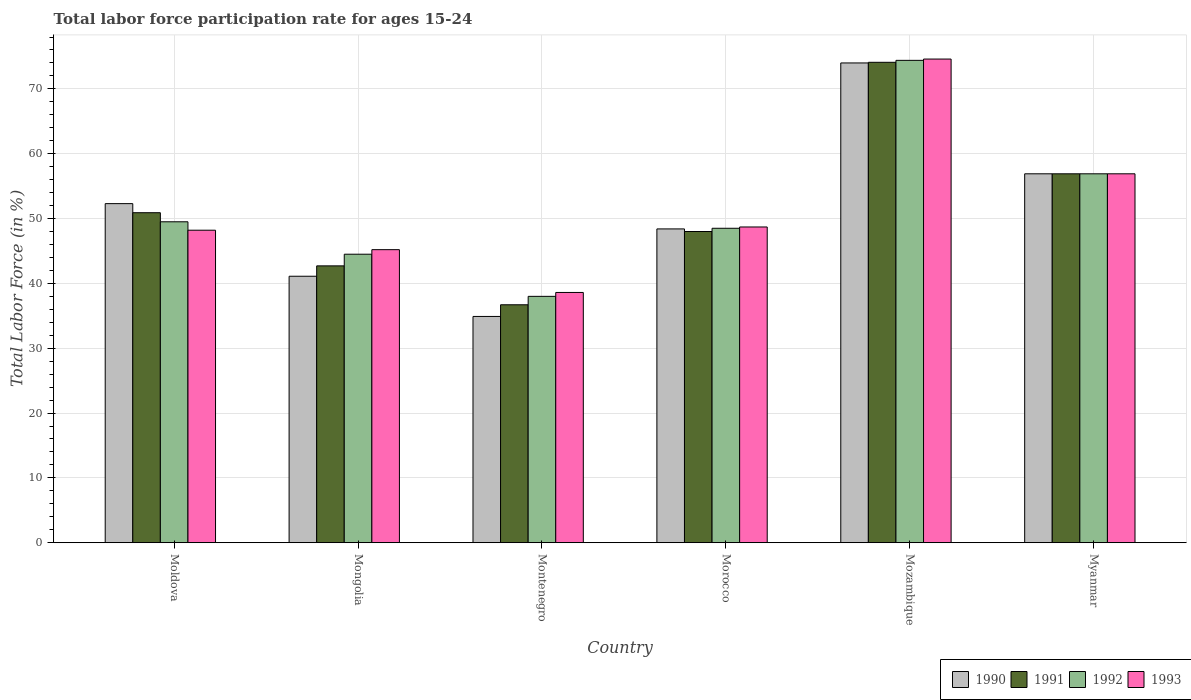How many groups of bars are there?
Provide a succinct answer. 6. Are the number of bars on each tick of the X-axis equal?
Give a very brief answer. Yes. How many bars are there on the 2nd tick from the left?
Ensure brevity in your answer.  4. How many bars are there on the 4th tick from the right?
Your answer should be very brief. 4. What is the label of the 1st group of bars from the left?
Give a very brief answer. Moldova. In how many cases, is the number of bars for a given country not equal to the number of legend labels?
Your response must be concise. 0. What is the labor force participation rate in 1992 in Montenegro?
Provide a succinct answer. 38. Across all countries, what is the maximum labor force participation rate in 1992?
Offer a very short reply. 74.4. Across all countries, what is the minimum labor force participation rate in 1992?
Make the answer very short. 38. In which country was the labor force participation rate in 1993 maximum?
Offer a very short reply. Mozambique. In which country was the labor force participation rate in 1992 minimum?
Make the answer very short. Montenegro. What is the total labor force participation rate in 1991 in the graph?
Provide a succinct answer. 309.3. What is the difference between the labor force participation rate in 1990 in Mongolia and the labor force participation rate in 1992 in Montenegro?
Make the answer very short. 3.1. What is the average labor force participation rate in 1993 per country?
Your answer should be compact. 52.03. What is the difference between the labor force participation rate of/in 1992 and labor force participation rate of/in 1991 in Montenegro?
Your answer should be very brief. 1.3. In how many countries, is the labor force participation rate in 1991 greater than 6 %?
Give a very brief answer. 6. What is the ratio of the labor force participation rate in 1990 in Mongolia to that in Mozambique?
Offer a very short reply. 0.56. Is the labor force participation rate in 1993 in Montenegro less than that in Myanmar?
Your answer should be very brief. Yes. What is the difference between the highest and the second highest labor force participation rate in 1990?
Make the answer very short. -17.1. What is the difference between the highest and the lowest labor force participation rate in 1992?
Make the answer very short. 36.4. In how many countries, is the labor force participation rate in 1990 greater than the average labor force participation rate in 1990 taken over all countries?
Keep it short and to the point. 3. Is it the case that in every country, the sum of the labor force participation rate in 1992 and labor force participation rate in 1990 is greater than the sum of labor force participation rate in 1993 and labor force participation rate in 1991?
Provide a short and direct response. No. Is it the case that in every country, the sum of the labor force participation rate in 1991 and labor force participation rate in 1993 is greater than the labor force participation rate in 1990?
Your answer should be very brief. Yes. How many bars are there?
Give a very brief answer. 24. Are the values on the major ticks of Y-axis written in scientific E-notation?
Keep it short and to the point. No. Does the graph contain any zero values?
Give a very brief answer. No. Does the graph contain grids?
Your answer should be very brief. Yes. How are the legend labels stacked?
Your response must be concise. Horizontal. What is the title of the graph?
Make the answer very short. Total labor force participation rate for ages 15-24. Does "1986" appear as one of the legend labels in the graph?
Offer a very short reply. No. What is the label or title of the X-axis?
Make the answer very short. Country. What is the Total Labor Force (in %) of 1990 in Moldova?
Your answer should be compact. 52.3. What is the Total Labor Force (in %) in 1991 in Moldova?
Make the answer very short. 50.9. What is the Total Labor Force (in %) in 1992 in Moldova?
Offer a very short reply. 49.5. What is the Total Labor Force (in %) in 1993 in Moldova?
Offer a terse response. 48.2. What is the Total Labor Force (in %) of 1990 in Mongolia?
Your response must be concise. 41.1. What is the Total Labor Force (in %) of 1991 in Mongolia?
Ensure brevity in your answer.  42.7. What is the Total Labor Force (in %) in 1992 in Mongolia?
Make the answer very short. 44.5. What is the Total Labor Force (in %) of 1993 in Mongolia?
Offer a terse response. 45.2. What is the Total Labor Force (in %) in 1990 in Montenegro?
Give a very brief answer. 34.9. What is the Total Labor Force (in %) in 1991 in Montenegro?
Your answer should be very brief. 36.7. What is the Total Labor Force (in %) of 1992 in Montenegro?
Offer a very short reply. 38. What is the Total Labor Force (in %) in 1993 in Montenegro?
Provide a succinct answer. 38.6. What is the Total Labor Force (in %) in 1990 in Morocco?
Give a very brief answer. 48.4. What is the Total Labor Force (in %) in 1992 in Morocco?
Make the answer very short. 48.5. What is the Total Labor Force (in %) in 1993 in Morocco?
Your answer should be very brief. 48.7. What is the Total Labor Force (in %) in 1990 in Mozambique?
Provide a succinct answer. 74. What is the Total Labor Force (in %) in 1991 in Mozambique?
Your response must be concise. 74.1. What is the Total Labor Force (in %) of 1992 in Mozambique?
Your answer should be compact. 74.4. What is the Total Labor Force (in %) of 1993 in Mozambique?
Give a very brief answer. 74.6. What is the Total Labor Force (in %) of 1990 in Myanmar?
Provide a short and direct response. 56.9. What is the Total Labor Force (in %) in 1991 in Myanmar?
Your response must be concise. 56.9. What is the Total Labor Force (in %) in 1992 in Myanmar?
Offer a very short reply. 56.9. What is the Total Labor Force (in %) in 1993 in Myanmar?
Offer a very short reply. 56.9. Across all countries, what is the maximum Total Labor Force (in %) in 1991?
Keep it short and to the point. 74.1. Across all countries, what is the maximum Total Labor Force (in %) of 1992?
Give a very brief answer. 74.4. Across all countries, what is the maximum Total Labor Force (in %) in 1993?
Provide a succinct answer. 74.6. Across all countries, what is the minimum Total Labor Force (in %) in 1990?
Your answer should be compact. 34.9. Across all countries, what is the minimum Total Labor Force (in %) in 1991?
Ensure brevity in your answer.  36.7. Across all countries, what is the minimum Total Labor Force (in %) of 1992?
Provide a succinct answer. 38. Across all countries, what is the minimum Total Labor Force (in %) of 1993?
Offer a terse response. 38.6. What is the total Total Labor Force (in %) in 1990 in the graph?
Make the answer very short. 307.6. What is the total Total Labor Force (in %) of 1991 in the graph?
Your response must be concise. 309.3. What is the total Total Labor Force (in %) of 1992 in the graph?
Offer a very short reply. 311.8. What is the total Total Labor Force (in %) in 1993 in the graph?
Ensure brevity in your answer.  312.2. What is the difference between the Total Labor Force (in %) of 1993 in Moldova and that in Mongolia?
Your answer should be very brief. 3. What is the difference between the Total Labor Force (in %) in 1992 in Moldova and that in Montenegro?
Offer a terse response. 11.5. What is the difference between the Total Labor Force (in %) of 1991 in Moldova and that in Morocco?
Your answer should be very brief. 2.9. What is the difference between the Total Labor Force (in %) of 1992 in Moldova and that in Morocco?
Offer a terse response. 1. What is the difference between the Total Labor Force (in %) in 1993 in Moldova and that in Morocco?
Offer a very short reply. -0.5. What is the difference between the Total Labor Force (in %) in 1990 in Moldova and that in Mozambique?
Give a very brief answer. -21.7. What is the difference between the Total Labor Force (in %) of 1991 in Moldova and that in Mozambique?
Provide a short and direct response. -23.2. What is the difference between the Total Labor Force (in %) of 1992 in Moldova and that in Mozambique?
Offer a very short reply. -24.9. What is the difference between the Total Labor Force (in %) in 1993 in Moldova and that in Mozambique?
Your answer should be compact. -26.4. What is the difference between the Total Labor Force (in %) in 1990 in Moldova and that in Myanmar?
Offer a very short reply. -4.6. What is the difference between the Total Labor Force (in %) in 1991 in Moldova and that in Myanmar?
Keep it short and to the point. -6. What is the difference between the Total Labor Force (in %) of 1991 in Mongolia and that in Montenegro?
Make the answer very short. 6. What is the difference between the Total Labor Force (in %) of 1992 in Mongolia and that in Montenegro?
Offer a terse response. 6.5. What is the difference between the Total Labor Force (in %) in 1993 in Mongolia and that in Montenegro?
Keep it short and to the point. 6.6. What is the difference between the Total Labor Force (in %) of 1990 in Mongolia and that in Morocco?
Your answer should be very brief. -7.3. What is the difference between the Total Labor Force (in %) of 1992 in Mongolia and that in Morocco?
Provide a succinct answer. -4. What is the difference between the Total Labor Force (in %) of 1990 in Mongolia and that in Mozambique?
Make the answer very short. -32.9. What is the difference between the Total Labor Force (in %) in 1991 in Mongolia and that in Mozambique?
Make the answer very short. -31.4. What is the difference between the Total Labor Force (in %) of 1992 in Mongolia and that in Mozambique?
Provide a short and direct response. -29.9. What is the difference between the Total Labor Force (in %) of 1993 in Mongolia and that in Mozambique?
Your response must be concise. -29.4. What is the difference between the Total Labor Force (in %) of 1990 in Mongolia and that in Myanmar?
Your response must be concise. -15.8. What is the difference between the Total Labor Force (in %) in 1992 in Mongolia and that in Myanmar?
Make the answer very short. -12.4. What is the difference between the Total Labor Force (in %) of 1991 in Montenegro and that in Morocco?
Your response must be concise. -11.3. What is the difference between the Total Labor Force (in %) in 1990 in Montenegro and that in Mozambique?
Your answer should be very brief. -39.1. What is the difference between the Total Labor Force (in %) in 1991 in Montenegro and that in Mozambique?
Your answer should be compact. -37.4. What is the difference between the Total Labor Force (in %) in 1992 in Montenegro and that in Mozambique?
Your answer should be very brief. -36.4. What is the difference between the Total Labor Force (in %) in 1993 in Montenegro and that in Mozambique?
Offer a very short reply. -36. What is the difference between the Total Labor Force (in %) of 1990 in Montenegro and that in Myanmar?
Make the answer very short. -22. What is the difference between the Total Labor Force (in %) in 1991 in Montenegro and that in Myanmar?
Provide a short and direct response. -20.2. What is the difference between the Total Labor Force (in %) in 1992 in Montenegro and that in Myanmar?
Give a very brief answer. -18.9. What is the difference between the Total Labor Force (in %) of 1993 in Montenegro and that in Myanmar?
Keep it short and to the point. -18.3. What is the difference between the Total Labor Force (in %) of 1990 in Morocco and that in Mozambique?
Your answer should be very brief. -25.6. What is the difference between the Total Labor Force (in %) of 1991 in Morocco and that in Mozambique?
Keep it short and to the point. -26.1. What is the difference between the Total Labor Force (in %) in 1992 in Morocco and that in Mozambique?
Ensure brevity in your answer.  -25.9. What is the difference between the Total Labor Force (in %) in 1993 in Morocco and that in Mozambique?
Offer a very short reply. -25.9. What is the difference between the Total Labor Force (in %) of 1990 in Morocco and that in Myanmar?
Provide a succinct answer. -8.5. What is the difference between the Total Labor Force (in %) in 1991 in Morocco and that in Myanmar?
Provide a short and direct response. -8.9. What is the difference between the Total Labor Force (in %) of 1993 in Morocco and that in Myanmar?
Provide a short and direct response. -8.2. What is the difference between the Total Labor Force (in %) of 1992 in Mozambique and that in Myanmar?
Provide a short and direct response. 17.5. What is the difference between the Total Labor Force (in %) of 1993 in Mozambique and that in Myanmar?
Ensure brevity in your answer.  17.7. What is the difference between the Total Labor Force (in %) of 1990 in Moldova and the Total Labor Force (in %) of 1992 in Mongolia?
Keep it short and to the point. 7.8. What is the difference between the Total Labor Force (in %) in 1990 in Moldova and the Total Labor Force (in %) in 1993 in Montenegro?
Provide a succinct answer. 13.7. What is the difference between the Total Labor Force (in %) of 1991 in Moldova and the Total Labor Force (in %) of 1992 in Montenegro?
Provide a short and direct response. 12.9. What is the difference between the Total Labor Force (in %) of 1991 in Moldova and the Total Labor Force (in %) of 1993 in Montenegro?
Your answer should be very brief. 12.3. What is the difference between the Total Labor Force (in %) in 1992 in Moldova and the Total Labor Force (in %) in 1993 in Montenegro?
Give a very brief answer. 10.9. What is the difference between the Total Labor Force (in %) of 1991 in Moldova and the Total Labor Force (in %) of 1992 in Morocco?
Offer a terse response. 2.4. What is the difference between the Total Labor Force (in %) in 1991 in Moldova and the Total Labor Force (in %) in 1993 in Morocco?
Your response must be concise. 2.2. What is the difference between the Total Labor Force (in %) in 1992 in Moldova and the Total Labor Force (in %) in 1993 in Morocco?
Give a very brief answer. 0.8. What is the difference between the Total Labor Force (in %) of 1990 in Moldova and the Total Labor Force (in %) of 1991 in Mozambique?
Provide a succinct answer. -21.8. What is the difference between the Total Labor Force (in %) in 1990 in Moldova and the Total Labor Force (in %) in 1992 in Mozambique?
Offer a terse response. -22.1. What is the difference between the Total Labor Force (in %) in 1990 in Moldova and the Total Labor Force (in %) in 1993 in Mozambique?
Ensure brevity in your answer.  -22.3. What is the difference between the Total Labor Force (in %) in 1991 in Moldova and the Total Labor Force (in %) in 1992 in Mozambique?
Provide a succinct answer. -23.5. What is the difference between the Total Labor Force (in %) in 1991 in Moldova and the Total Labor Force (in %) in 1993 in Mozambique?
Provide a succinct answer. -23.7. What is the difference between the Total Labor Force (in %) in 1992 in Moldova and the Total Labor Force (in %) in 1993 in Mozambique?
Provide a succinct answer. -25.1. What is the difference between the Total Labor Force (in %) of 1990 in Moldova and the Total Labor Force (in %) of 1991 in Myanmar?
Ensure brevity in your answer.  -4.6. What is the difference between the Total Labor Force (in %) in 1990 in Moldova and the Total Labor Force (in %) in 1992 in Myanmar?
Provide a short and direct response. -4.6. What is the difference between the Total Labor Force (in %) of 1990 in Moldova and the Total Labor Force (in %) of 1993 in Myanmar?
Offer a very short reply. -4.6. What is the difference between the Total Labor Force (in %) of 1991 in Moldova and the Total Labor Force (in %) of 1992 in Myanmar?
Ensure brevity in your answer.  -6. What is the difference between the Total Labor Force (in %) in 1990 in Mongolia and the Total Labor Force (in %) in 1991 in Montenegro?
Offer a very short reply. 4.4. What is the difference between the Total Labor Force (in %) of 1990 in Mongolia and the Total Labor Force (in %) of 1993 in Montenegro?
Provide a short and direct response. 2.5. What is the difference between the Total Labor Force (in %) in 1992 in Mongolia and the Total Labor Force (in %) in 1993 in Montenegro?
Your answer should be very brief. 5.9. What is the difference between the Total Labor Force (in %) in 1990 in Mongolia and the Total Labor Force (in %) in 1993 in Morocco?
Make the answer very short. -7.6. What is the difference between the Total Labor Force (in %) in 1991 in Mongolia and the Total Labor Force (in %) in 1992 in Morocco?
Keep it short and to the point. -5.8. What is the difference between the Total Labor Force (in %) in 1991 in Mongolia and the Total Labor Force (in %) in 1993 in Morocco?
Provide a short and direct response. -6. What is the difference between the Total Labor Force (in %) of 1992 in Mongolia and the Total Labor Force (in %) of 1993 in Morocco?
Your answer should be compact. -4.2. What is the difference between the Total Labor Force (in %) in 1990 in Mongolia and the Total Labor Force (in %) in 1991 in Mozambique?
Give a very brief answer. -33. What is the difference between the Total Labor Force (in %) of 1990 in Mongolia and the Total Labor Force (in %) of 1992 in Mozambique?
Your response must be concise. -33.3. What is the difference between the Total Labor Force (in %) of 1990 in Mongolia and the Total Labor Force (in %) of 1993 in Mozambique?
Your response must be concise. -33.5. What is the difference between the Total Labor Force (in %) of 1991 in Mongolia and the Total Labor Force (in %) of 1992 in Mozambique?
Make the answer very short. -31.7. What is the difference between the Total Labor Force (in %) of 1991 in Mongolia and the Total Labor Force (in %) of 1993 in Mozambique?
Provide a succinct answer. -31.9. What is the difference between the Total Labor Force (in %) of 1992 in Mongolia and the Total Labor Force (in %) of 1993 in Mozambique?
Provide a short and direct response. -30.1. What is the difference between the Total Labor Force (in %) in 1990 in Mongolia and the Total Labor Force (in %) in 1991 in Myanmar?
Your answer should be compact. -15.8. What is the difference between the Total Labor Force (in %) in 1990 in Mongolia and the Total Labor Force (in %) in 1992 in Myanmar?
Your response must be concise. -15.8. What is the difference between the Total Labor Force (in %) of 1990 in Mongolia and the Total Labor Force (in %) of 1993 in Myanmar?
Keep it short and to the point. -15.8. What is the difference between the Total Labor Force (in %) in 1991 in Mongolia and the Total Labor Force (in %) in 1992 in Myanmar?
Your answer should be compact. -14.2. What is the difference between the Total Labor Force (in %) of 1990 in Montenegro and the Total Labor Force (in %) of 1993 in Morocco?
Offer a very short reply. -13.8. What is the difference between the Total Labor Force (in %) in 1991 in Montenegro and the Total Labor Force (in %) in 1992 in Morocco?
Give a very brief answer. -11.8. What is the difference between the Total Labor Force (in %) of 1991 in Montenegro and the Total Labor Force (in %) of 1993 in Morocco?
Provide a succinct answer. -12. What is the difference between the Total Labor Force (in %) of 1990 in Montenegro and the Total Labor Force (in %) of 1991 in Mozambique?
Ensure brevity in your answer.  -39.2. What is the difference between the Total Labor Force (in %) of 1990 in Montenegro and the Total Labor Force (in %) of 1992 in Mozambique?
Keep it short and to the point. -39.5. What is the difference between the Total Labor Force (in %) of 1990 in Montenegro and the Total Labor Force (in %) of 1993 in Mozambique?
Give a very brief answer. -39.7. What is the difference between the Total Labor Force (in %) of 1991 in Montenegro and the Total Labor Force (in %) of 1992 in Mozambique?
Ensure brevity in your answer.  -37.7. What is the difference between the Total Labor Force (in %) in 1991 in Montenegro and the Total Labor Force (in %) in 1993 in Mozambique?
Your response must be concise. -37.9. What is the difference between the Total Labor Force (in %) of 1992 in Montenegro and the Total Labor Force (in %) of 1993 in Mozambique?
Ensure brevity in your answer.  -36.6. What is the difference between the Total Labor Force (in %) of 1991 in Montenegro and the Total Labor Force (in %) of 1992 in Myanmar?
Give a very brief answer. -20.2. What is the difference between the Total Labor Force (in %) in 1991 in Montenegro and the Total Labor Force (in %) in 1993 in Myanmar?
Keep it short and to the point. -20.2. What is the difference between the Total Labor Force (in %) in 1992 in Montenegro and the Total Labor Force (in %) in 1993 in Myanmar?
Provide a short and direct response. -18.9. What is the difference between the Total Labor Force (in %) in 1990 in Morocco and the Total Labor Force (in %) in 1991 in Mozambique?
Your response must be concise. -25.7. What is the difference between the Total Labor Force (in %) in 1990 in Morocco and the Total Labor Force (in %) in 1993 in Mozambique?
Your answer should be compact. -26.2. What is the difference between the Total Labor Force (in %) of 1991 in Morocco and the Total Labor Force (in %) of 1992 in Mozambique?
Your response must be concise. -26.4. What is the difference between the Total Labor Force (in %) of 1991 in Morocco and the Total Labor Force (in %) of 1993 in Mozambique?
Your answer should be compact. -26.6. What is the difference between the Total Labor Force (in %) in 1992 in Morocco and the Total Labor Force (in %) in 1993 in Mozambique?
Your answer should be very brief. -26.1. What is the difference between the Total Labor Force (in %) of 1990 in Morocco and the Total Labor Force (in %) of 1991 in Myanmar?
Keep it short and to the point. -8.5. What is the difference between the Total Labor Force (in %) in 1990 in Morocco and the Total Labor Force (in %) in 1992 in Myanmar?
Offer a very short reply. -8.5. What is the difference between the Total Labor Force (in %) in 1991 in Morocco and the Total Labor Force (in %) in 1992 in Myanmar?
Your response must be concise. -8.9. What is the difference between the Total Labor Force (in %) of 1991 in Morocco and the Total Labor Force (in %) of 1993 in Myanmar?
Your answer should be very brief. -8.9. What is the difference between the Total Labor Force (in %) of 1992 in Morocco and the Total Labor Force (in %) of 1993 in Myanmar?
Ensure brevity in your answer.  -8.4. What is the difference between the Total Labor Force (in %) of 1990 in Mozambique and the Total Labor Force (in %) of 1991 in Myanmar?
Provide a succinct answer. 17.1. What is the difference between the Total Labor Force (in %) of 1992 in Mozambique and the Total Labor Force (in %) of 1993 in Myanmar?
Provide a succinct answer. 17.5. What is the average Total Labor Force (in %) in 1990 per country?
Your answer should be compact. 51.27. What is the average Total Labor Force (in %) in 1991 per country?
Offer a terse response. 51.55. What is the average Total Labor Force (in %) of 1992 per country?
Give a very brief answer. 51.97. What is the average Total Labor Force (in %) in 1993 per country?
Offer a terse response. 52.03. What is the difference between the Total Labor Force (in %) in 1990 and Total Labor Force (in %) in 1992 in Moldova?
Ensure brevity in your answer.  2.8. What is the difference between the Total Labor Force (in %) of 1990 and Total Labor Force (in %) of 1993 in Moldova?
Provide a succinct answer. 4.1. What is the difference between the Total Labor Force (in %) in 1991 and Total Labor Force (in %) in 1992 in Moldova?
Provide a succinct answer. 1.4. What is the difference between the Total Labor Force (in %) in 1990 and Total Labor Force (in %) in 1992 in Mongolia?
Keep it short and to the point. -3.4. What is the difference between the Total Labor Force (in %) of 1991 and Total Labor Force (in %) of 1992 in Mongolia?
Your response must be concise. -1.8. What is the difference between the Total Labor Force (in %) of 1992 and Total Labor Force (in %) of 1993 in Mongolia?
Make the answer very short. -0.7. What is the difference between the Total Labor Force (in %) of 1990 and Total Labor Force (in %) of 1992 in Montenegro?
Make the answer very short. -3.1. What is the difference between the Total Labor Force (in %) in 1991 and Total Labor Force (in %) in 1992 in Montenegro?
Your response must be concise. -1.3. What is the difference between the Total Labor Force (in %) in 1992 and Total Labor Force (in %) in 1993 in Montenegro?
Make the answer very short. -0.6. What is the difference between the Total Labor Force (in %) in 1991 and Total Labor Force (in %) in 1992 in Morocco?
Offer a very short reply. -0.5. What is the difference between the Total Labor Force (in %) in 1990 and Total Labor Force (in %) in 1991 in Mozambique?
Give a very brief answer. -0.1. What is the difference between the Total Labor Force (in %) of 1990 and Total Labor Force (in %) of 1992 in Mozambique?
Your answer should be compact. -0.4. What is the difference between the Total Labor Force (in %) in 1990 and Total Labor Force (in %) in 1993 in Mozambique?
Your answer should be very brief. -0.6. What is the difference between the Total Labor Force (in %) of 1991 and Total Labor Force (in %) of 1993 in Myanmar?
Offer a terse response. 0. What is the difference between the Total Labor Force (in %) of 1992 and Total Labor Force (in %) of 1993 in Myanmar?
Your answer should be very brief. 0. What is the ratio of the Total Labor Force (in %) of 1990 in Moldova to that in Mongolia?
Give a very brief answer. 1.27. What is the ratio of the Total Labor Force (in %) in 1991 in Moldova to that in Mongolia?
Make the answer very short. 1.19. What is the ratio of the Total Labor Force (in %) in 1992 in Moldova to that in Mongolia?
Offer a very short reply. 1.11. What is the ratio of the Total Labor Force (in %) of 1993 in Moldova to that in Mongolia?
Give a very brief answer. 1.07. What is the ratio of the Total Labor Force (in %) of 1990 in Moldova to that in Montenegro?
Offer a terse response. 1.5. What is the ratio of the Total Labor Force (in %) of 1991 in Moldova to that in Montenegro?
Offer a very short reply. 1.39. What is the ratio of the Total Labor Force (in %) of 1992 in Moldova to that in Montenegro?
Your response must be concise. 1.3. What is the ratio of the Total Labor Force (in %) in 1993 in Moldova to that in Montenegro?
Your response must be concise. 1.25. What is the ratio of the Total Labor Force (in %) in 1990 in Moldova to that in Morocco?
Keep it short and to the point. 1.08. What is the ratio of the Total Labor Force (in %) of 1991 in Moldova to that in Morocco?
Offer a terse response. 1.06. What is the ratio of the Total Labor Force (in %) in 1992 in Moldova to that in Morocco?
Ensure brevity in your answer.  1.02. What is the ratio of the Total Labor Force (in %) in 1990 in Moldova to that in Mozambique?
Your answer should be compact. 0.71. What is the ratio of the Total Labor Force (in %) of 1991 in Moldova to that in Mozambique?
Offer a very short reply. 0.69. What is the ratio of the Total Labor Force (in %) of 1992 in Moldova to that in Mozambique?
Ensure brevity in your answer.  0.67. What is the ratio of the Total Labor Force (in %) of 1993 in Moldova to that in Mozambique?
Keep it short and to the point. 0.65. What is the ratio of the Total Labor Force (in %) of 1990 in Moldova to that in Myanmar?
Provide a succinct answer. 0.92. What is the ratio of the Total Labor Force (in %) in 1991 in Moldova to that in Myanmar?
Make the answer very short. 0.89. What is the ratio of the Total Labor Force (in %) of 1992 in Moldova to that in Myanmar?
Your answer should be compact. 0.87. What is the ratio of the Total Labor Force (in %) in 1993 in Moldova to that in Myanmar?
Your answer should be very brief. 0.85. What is the ratio of the Total Labor Force (in %) in 1990 in Mongolia to that in Montenegro?
Offer a very short reply. 1.18. What is the ratio of the Total Labor Force (in %) in 1991 in Mongolia to that in Montenegro?
Give a very brief answer. 1.16. What is the ratio of the Total Labor Force (in %) of 1992 in Mongolia to that in Montenegro?
Offer a very short reply. 1.17. What is the ratio of the Total Labor Force (in %) in 1993 in Mongolia to that in Montenegro?
Make the answer very short. 1.17. What is the ratio of the Total Labor Force (in %) in 1990 in Mongolia to that in Morocco?
Provide a short and direct response. 0.85. What is the ratio of the Total Labor Force (in %) of 1991 in Mongolia to that in Morocco?
Offer a very short reply. 0.89. What is the ratio of the Total Labor Force (in %) of 1992 in Mongolia to that in Morocco?
Keep it short and to the point. 0.92. What is the ratio of the Total Labor Force (in %) of 1993 in Mongolia to that in Morocco?
Provide a short and direct response. 0.93. What is the ratio of the Total Labor Force (in %) in 1990 in Mongolia to that in Mozambique?
Ensure brevity in your answer.  0.56. What is the ratio of the Total Labor Force (in %) in 1991 in Mongolia to that in Mozambique?
Offer a very short reply. 0.58. What is the ratio of the Total Labor Force (in %) of 1992 in Mongolia to that in Mozambique?
Keep it short and to the point. 0.6. What is the ratio of the Total Labor Force (in %) in 1993 in Mongolia to that in Mozambique?
Offer a terse response. 0.61. What is the ratio of the Total Labor Force (in %) in 1990 in Mongolia to that in Myanmar?
Offer a very short reply. 0.72. What is the ratio of the Total Labor Force (in %) of 1991 in Mongolia to that in Myanmar?
Offer a very short reply. 0.75. What is the ratio of the Total Labor Force (in %) of 1992 in Mongolia to that in Myanmar?
Your answer should be compact. 0.78. What is the ratio of the Total Labor Force (in %) of 1993 in Mongolia to that in Myanmar?
Your answer should be compact. 0.79. What is the ratio of the Total Labor Force (in %) in 1990 in Montenegro to that in Morocco?
Your answer should be very brief. 0.72. What is the ratio of the Total Labor Force (in %) of 1991 in Montenegro to that in Morocco?
Keep it short and to the point. 0.76. What is the ratio of the Total Labor Force (in %) of 1992 in Montenegro to that in Morocco?
Your answer should be compact. 0.78. What is the ratio of the Total Labor Force (in %) in 1993 in Montenegro to that in Morocco?
Ensure brevity in your answer.  0.79. What is the ratio of the Total Labor Force (in %) of 1990 in Montenegro to that in Mozambique?
Offer a terse response. 0.47. What is the ratio of the Total Labor Force (in %) in 1991 in Montenegro to that in Mozambique?
Give a very brief answer. 0.5. What is the ratio of the Total Labor Force (in %) of 1992 in Montenegro to that in Mozambique?
Your response must be concise. 0.51. What is the ratio of the Total Labor Force (in %) in 1993 in Montenegro to that in Mozambique?
Ensure brevity in your answer.  0.52. What is the ratio of the Total Labor Force (in %) of 1990 in Montenegro to that in Myanmar?
Provide a short and direct response. 0.61. What is the ratio of the Total Labor Force (in %) in 1991 in Montenegro to that in Myanmar?
Provide a succinct answer. 0.65. What is the ratio of the Total Labor Force (in %) in 1992 in Montenegro to that in Myanmar?
Your answer should be compact. 0.67. What is the ratio of the Total Labor Force (in %) in 1993 in Montenegro to that in Myanmar?
Offer a terse response. 0.68. What is the ratio of the Total Labor Force (in %) in 1990 in Morocco to that in Mozambique?
Make the answer very short. 0.65. What is the ratio of the Total Labor Force (in %) in 1991 in Morocco to that in Mozambique?
Your answer should be compact. 0.65. What is the ratio of the Total Labor Force (in %) of 1992 in Morocco to that in Mozambique?
Keep it short and to the point. 0.65. What is the ratio of the Total Labor Force (in %) of 1993 in Morocco to that in Mozambique?
Your answer should be compact. 0.65. What is the ratio of the Total Labor Force (in %) of 1990 in Morocco to that in Myanmar?
Provide a short and direct response. 0.85. What is the ratio of the Total Labor Force (in %) in 1991 in Morocco to that in Myanmar?
Give a very brief answer. 0.84. What is the ratio of the Total Labor Force (in %) in 1992 in Morocco to that in Myanmar?
Keep it short and to the point. 0.85. What is the ratio of the Total Labor Force (in %) in 1993 in Morocco to that in Myanmar?
Your answer should be very brief. 0.86. What is the ratio of the Total Labor Force (in %) of 1990 in Mozambique to that in Myanmar?
Provide a succinct answer. 1.3. What is the ratio of the Total Labor Force (in %) in 1991 in Mozambique to that in Myanmar?
Offer a very short reply. 1.3. What is the ratio of the Total Labor Force (in %) in 1992 in Mozambique to that in Myanmar?
Your answer should be compact. 1.31. What is the ratio of the Total Labor Force (in %) in 1993 in Mozambique to that in Myanmar?
Offer a very short reply. 1.31. What is the difference between the highest and the second highest Total Labor Force (in %) in 1990?
Your response must be concise. 17.1. What is the difference between the highest and the second highest Total Labor Force (in %) of 1992?
Ensure brevity in your answer.  17.5. What is the difference between the highest and the second highest Total Labor Force (in %) in 1993?
Your answer should be very brief. 17.7. What is the difference between the highest and the lowest Total Labor Force (in %) in 1990?
Provide a short and direct response. 39.1. What is the difference between the highest and the lowest Total Labor Force (in %) of 1991?
Make the answer very short. 37.4. What is the difference between the highest and the lowest Total Labor Force (in %) of 1992?
Your answer should be compact. 36.4. What is the difference between the highest and the lowest Total Labor Force (in %) of 1993?
Your answer should be compact. 36. 